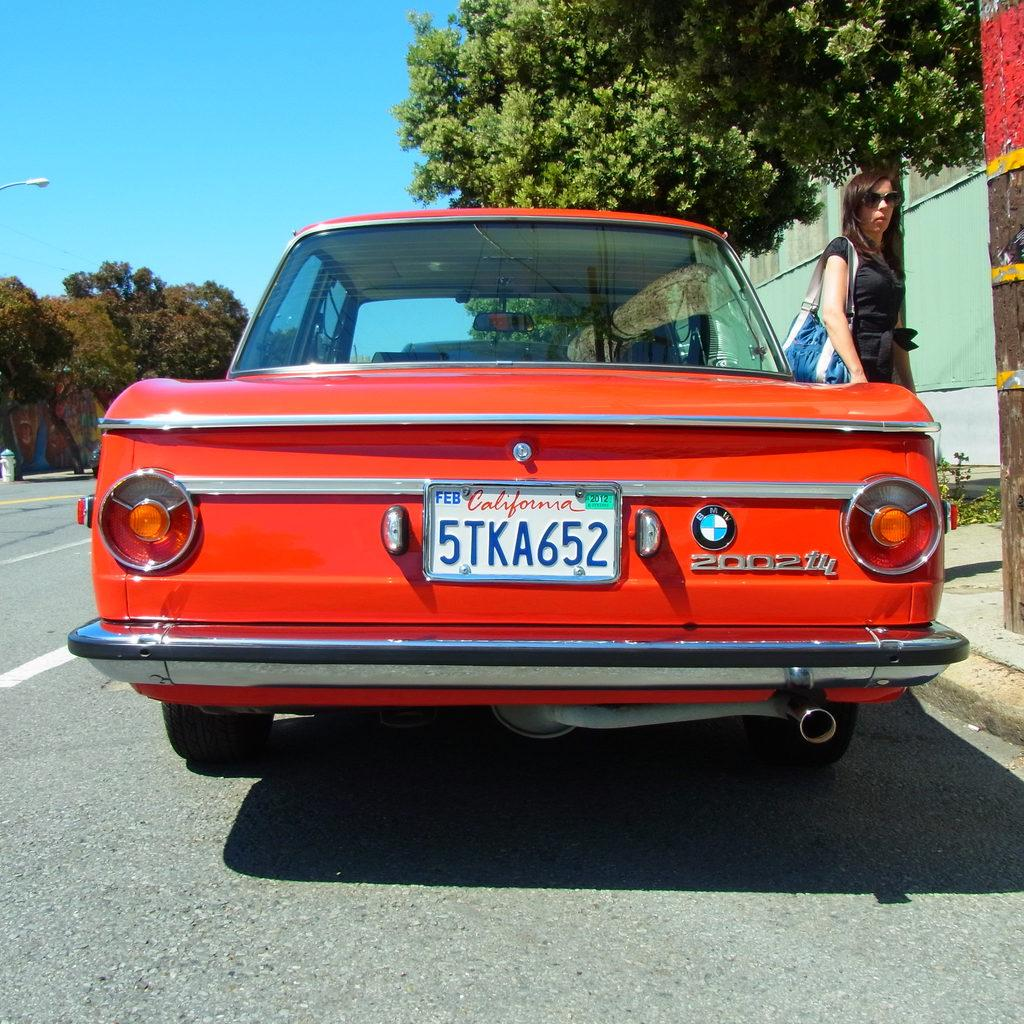What is the main subject of the image? There is a car on the road in the image. Are there any people in the image? Yes, there is a person walking in the image. What type of natural elements can be seen in the image? There are trees in the image. What type of man-made structures are present in the image? There are walls in the image. What is visible in the background of the image? The sky is visible in the image. What color object can be seen in the image? There is a white color object in the image. What type of coach can be seen in the image? There is no coach present in the image. What type of jewel is the person wearing in the image? There is no person wearing any jewelry in the image. 